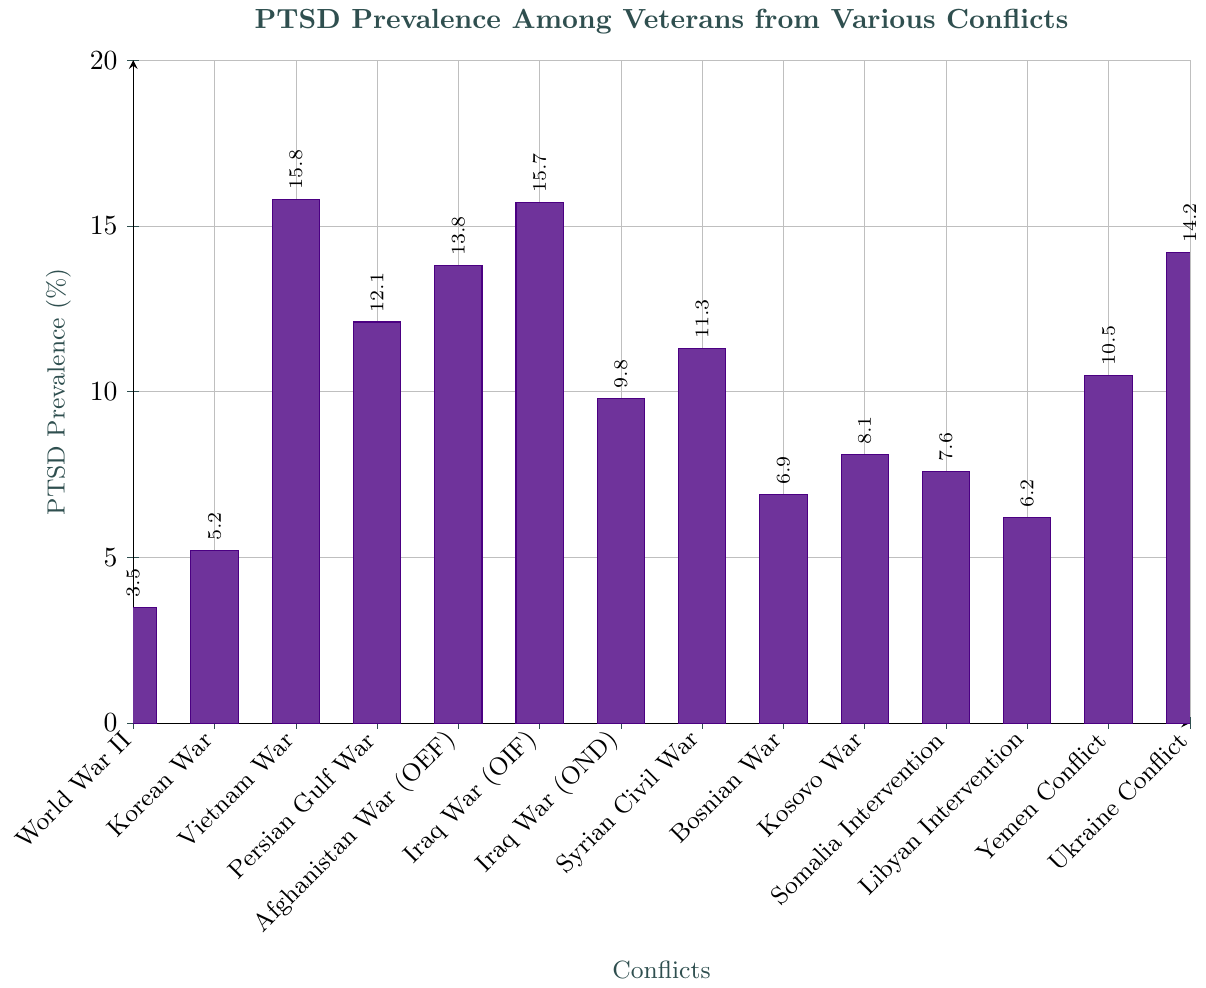What's the conflict with the highest PTSD prevalence? The figure shows the PTSD prevalence percentages for various conflicts. The highest bar represents the conflict with the highest prevalence percentage, which is the Vietnam War at 15.8%.
Answer: Vietnam War Which two conflicts have similar PTSD prevalence values close to 15%? By examining the heights of the bars, Vietnam War (15.8%) and Iraq War (OIF) (15.7%) have values close to 15%.
Answer: Vietnam War, Iraq War (OIF) What's the difference in PTSD prevalence between the Korean War and the Kosovo War? The PTSD prevalence for the Korean War is 5.2%, and for the Kosovo War, it is 8.1%. The difference is calculated as 8.1% - 5.2% = 2.9%.
Answer: 2.9% What's the average PTSD prevalence of conflicts that occurred in the 21st century? First, identify the 21st-century conflicts: Iraq War (OIF, OND), Afghanistan War (OEF), Syrian Civil War, Kosovo War, Somalia Intervention, Libyan Intervention, Yemen Conflict, Ukraine Conflict. The prevalence values are: 15.7, 9.8, 13.8, 11.3, 8.1, 7.6, 6.2, 10.5, and 14.2. The average is calculated by summing these values and dividing by the number of conflicts: (15.7+9.8+13.8+11.3+8.1+7.6+6.2+10.5+14.2)/9 = 10.9%.
Answer: 10.9% Compare the PTSD prevalence between the first and last listed conflicts. Which one is higher? The first listed conflict is World War II (3.5%), and the last listed conflict is Ukraine Conflict (14.2%). Comparing these values, the Ukraine Conflict has a higher PTSD prevalence.
Answer: Ukraine Conflict What is the median PTSD prevalence among all listed conflicts? List the prevalence values in ascending order: 3.5, 5.2, 6.2, 6.9, 7.6, 8.1, 9.8, 10.5, 11.3, 12.1, 13.8, 14.2, 15.7, 15.8. The median value is the middle number: (9.8 + 10.5) / 2 = 10.15%.
Answer: 10.15% How many conflicts have a PTSD prevalence above 10%? Count the conflicts with bars higher than the 10% mark: Vietnam War, Persian Gulf War, Afghanistan War (OEF), Iraq War (OIF), Iraq War (OND), Syrian Civil War, Yemen Conflict, Ukraine Conflict. There are 8 such conflicts.
Answer: 8 What percentage difference is there between the conflicts with the smallest and largest PTSD prevalence? The smallest PTSD prevalence is for World War II at 3.5%, and the largest is Vietnam War at 15.8%. The percentage difference is 15.8% - 3.5% = 12.3%.
Answer: 12.3% 